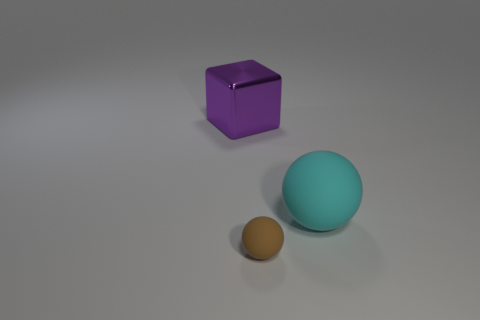Subtract all red spheres. Subtract all brown cylinders. How many spheres are left? 2 Subtract all blue cylinders. How many purple spheres are left? 0 Add 2 purples. How many big things exist? 0 Subtract all cyan rubber cubes. Subtract all large balls. How many objects are left? 2 Add 3 cyan rubber things. How many cyan rubber things are left? 4 Add 2 brown rubber balls. How many brown rubber balls exist? 3 Add 1 small rubber balls. How many objects exist? 4 Subtract all brown balls. How many balls are left? 1 Subtract 0 gray balls. How many objects are left? 3 Subtract all balls. How many objects are left? 1 